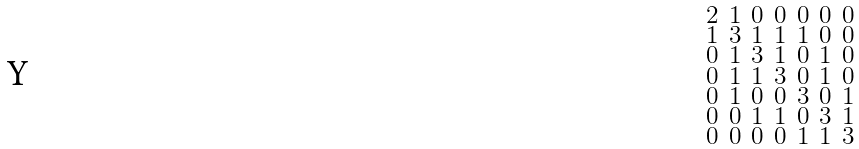<formula> <loc_0><loc_0><loc_500><loc_500>\begin{smallmatrix} 2 & 1 & 0 & 0 & 0 & 0 & 0 \\ 1 & 3 & 1 & 1 & 1 & 0 & 0 \\ 0 & 1 & 3 & 1 & 0 & 1 & 0 \\ 0 & 1 & 1 & 3 & 0 & 1 & 0 \\ 0 & 1 & 0 & 0 & 3 & 0 & 1 \\ 0 & 0 & 1 & 1 & 0 & 3 & 1 \\ 0 & 0 & 0 & 0 & 1 & 1 & 3 \end{smallmatrix}</formula> 